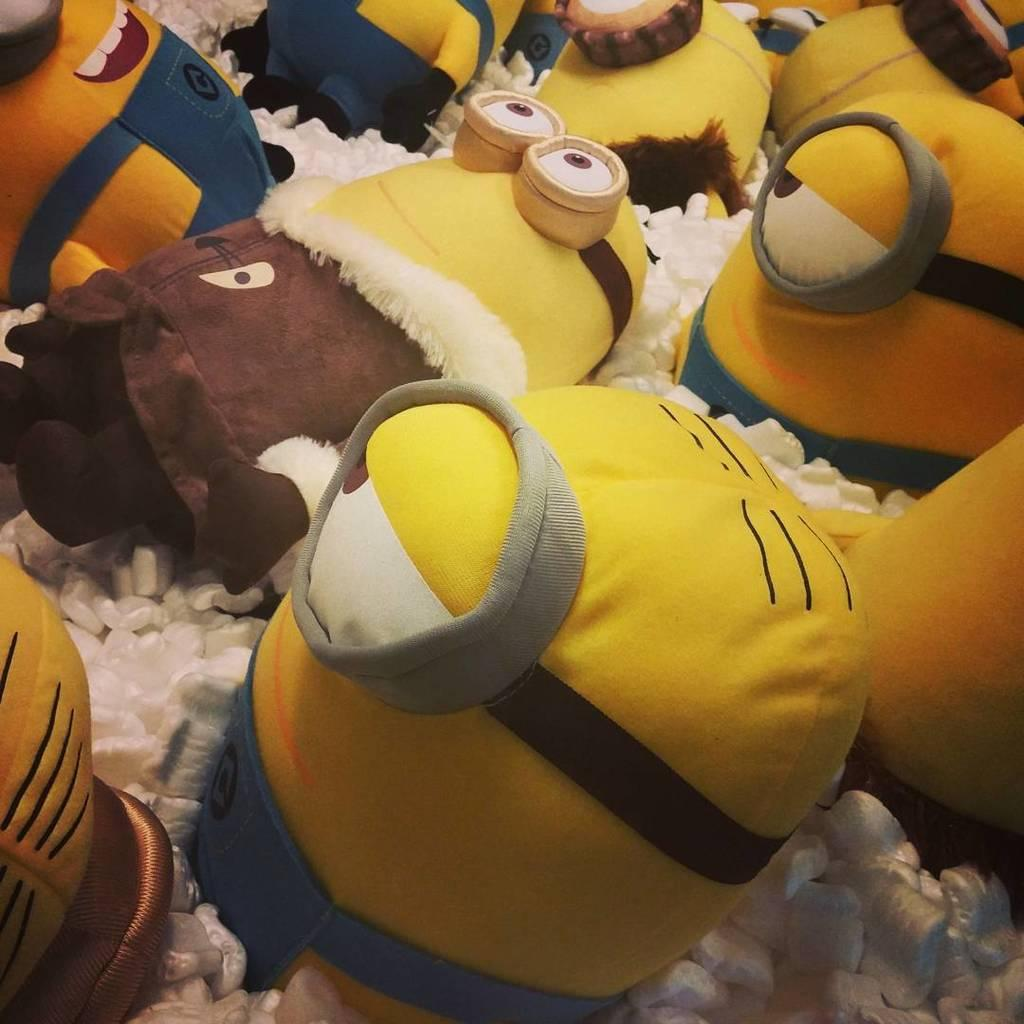What type of objects can be seen in the image? There are toys in the image. What is the color of the objects on which the toys are placed? The toys are on white color objects. What type of van is parked next to the toys in the image? There is no van present in the image; it only features toys on white color objects. 